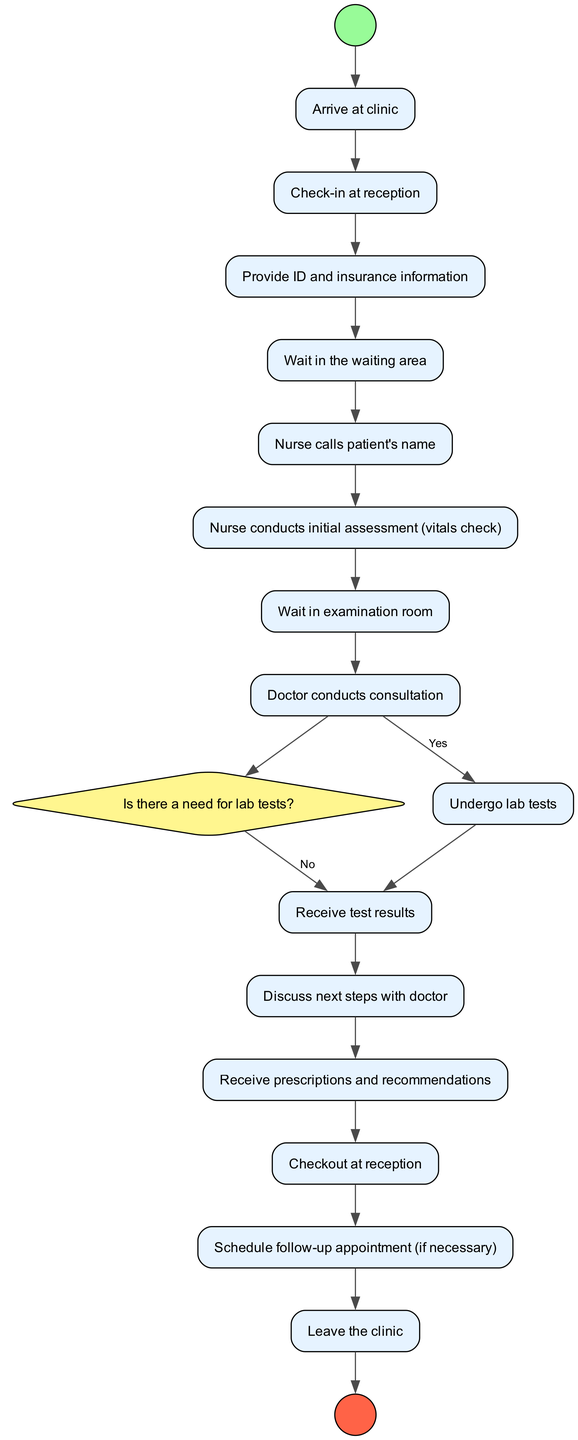What is the first action in the diagram? The first action node in the sequence is "Arrive at clinic." This is identified by looking at the diagram from the "Start" node, where the flow goes to the first action.
Answer: Arrive at clinic How many total action nodes are present? By counting all the nodes of type "Action" in the diagram, we find that there are eight of them. This includes all actions listed between the check-in and check-out processes.
Answer: Eight What follows after checking in at reception? After checking in at reception, the next action is "Provide ID and insurance information." This is derived from the direct flow following the "Check-in at reception" node.
Answer: Provide ID and insurance information What happens if lab tests are needed? If there is a need for lab tests, the next action that follows is "Undergo lab tests." This is determined by following the flow from the decision node to the corresponding action node when the condition is "Yes."
Answer: Undergo lab tests What is the final action before leaving the clinic? The final action before leaving the clinic is "Leave the clinic." This comes right before reaching the "End" node, thus concluding the activity diagram.
Answer: Leave the clinic How many total nodes are in the diagram? By adding the number of all nodes, including start, end, actions, and decision nodes, a total of sixteen nodes can be counted in the diagram.
Answer: Sixteen What is the purpose of the decision node in this diagram? The purpose of the decision node, labeled "Is there a need for lab tests?" is to direct the flow based on whether lab tests are required or not, impacting the subsequent actions performed.
Answer: Direct flow based on lab tests What are the two possible outcomes from the decision node? The two possible outcomes from the decision node are "Yes" and "No." These outcomes lead to different paths in the action sequence depending on the need for lab tests.
Answer: Yes and No 